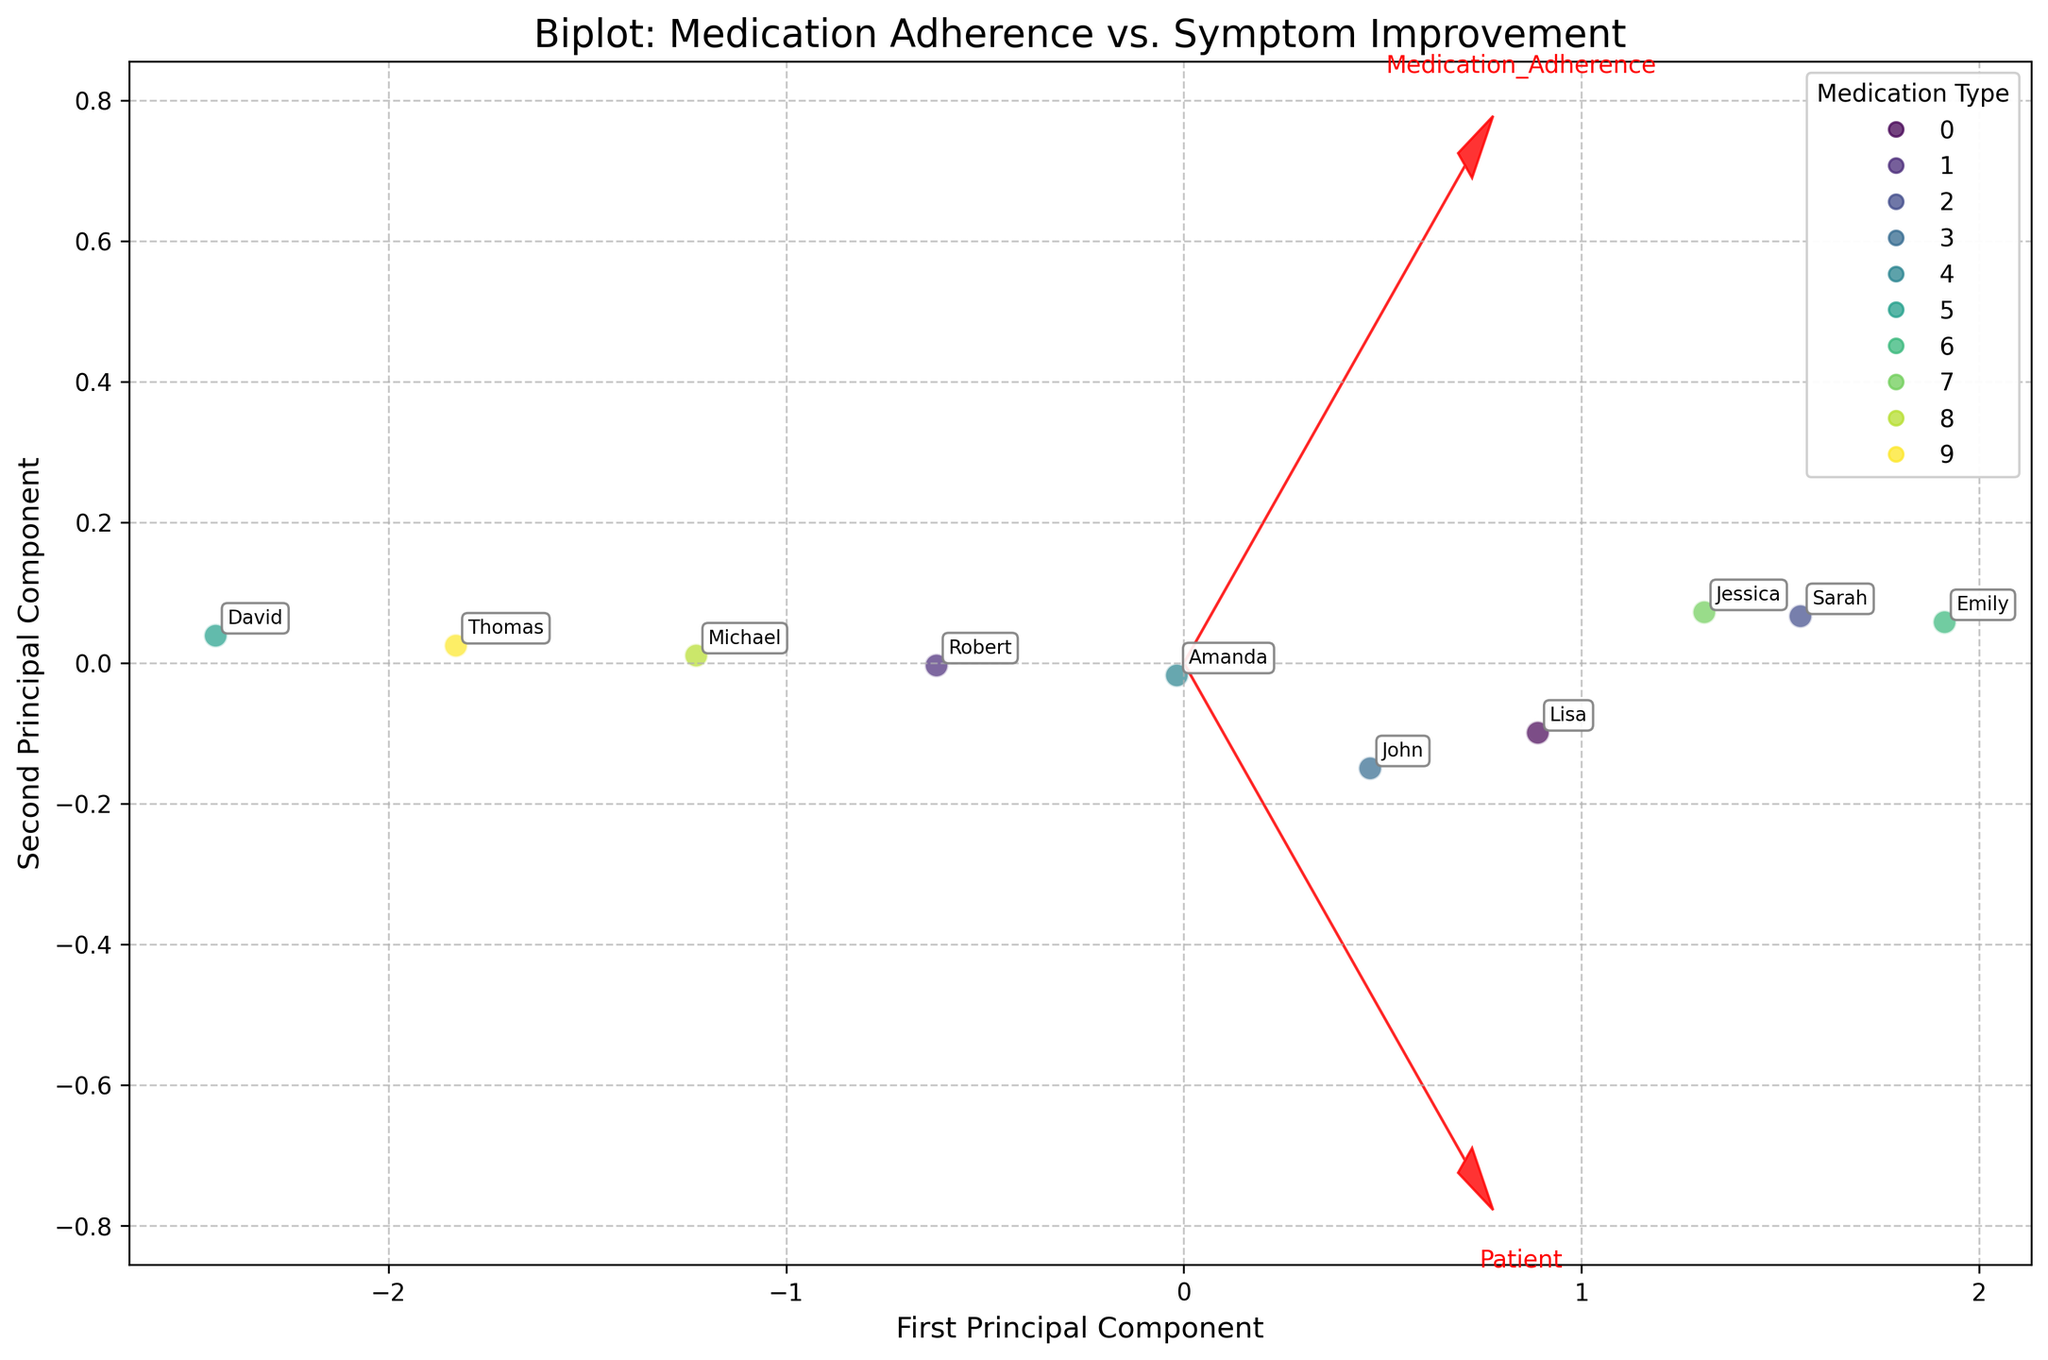How many patients are included in this biplot? The biplot includes data points for each patient, represented as individual points in the plot. Counting the annotations, there are 10 patients.
Answer: 10 What does the arrow direction indicate in this biplot? Arrows in a biplot represent the direction of maximum variance for the features (Medication Adherence and Symptom Improvement). They indicate the orientation and contribution of each original variable to the principal components.
Answer: Direction of maximum variance Which medication type shows the highest adherence and symptom improvement? By identifying the points positioned farthest along the positive axes for both medication adherence and symptom improvement, we can see that the point associated with "Quetiapine" (Emily) is the one with the highest values.
Answer: Quetiapine Is there a trend between medication adherence and symptom improvement visible in the biplot? Observing the general position of points, we can see that higher medication adherence generally correlates with higher symptom improvement, indicating a positive trend.
Answer: Positive trend Are there any outliers or patients who deviate significantly from the general pattern? If so, who are they? By looking for points that are distant or not following the main trend, David (Olanzapine) and Thomas (Ziprasidone) are noticeable for their relatively lower adherence and improvement.
Answer: David, Thomas What do the principal components represent in this biplot? The two principal components represent the directions of maximum variance in the dataset. The first principal component captures the highest variance, while the second component captures the second-highest variance orthogonally.
Answer: Directions of maximum variance Which gender has more representation in the high adherence and improvement area? Observing the annotations for gender and the placement of points, we see that females (e.g., Sarah, Emily, Jessica, Lisa) dominate the high adherence and improvement section.
Answer: Female From the biplot, can you identify the patient with the lowest adherence and symptom improvement? The point located closest to the lower left in the plot represents David, who has the lowest adherence (60) and symptom improvement (55).
Answer: David Do patients on atypical antipsychotics generally show better adherence and symptom improvement compared to other medications? Assessing the types of medications and their positions, patients on atypical antipsychotics (e.g., Quetiapine, Risperidone) are generally found towards the higher adherence and improvement area.
Answer: Yes 